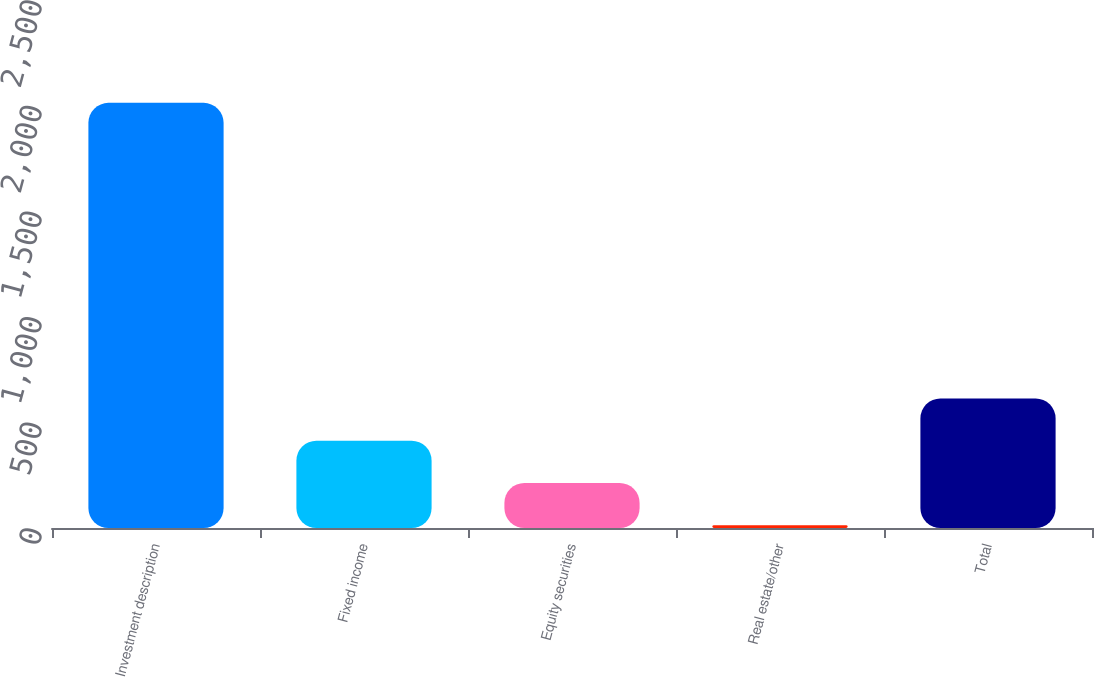<chart> <loc_0><loc_0><loc_500><loc_500><bar_chart><fcel>Investment description<fcel>Fixed income<fcel>Equity securities<fcel>Real estate/other<fcel>Total<nl><fcel>2013<fcel>413.48<fcel>213.54<fcel>13.6<fcel>613.42<nl></chart> 